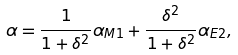<formula> <loc_0><loc_0><loc_500><loc_500>\alpha = \frac { 1 } { 1 + \delta ^ { 2 } } \alpha _ { M 1 } + \frac { \delta ^ { 2 } } { 1 + \delta ^ { 2 } } \alpha _ { E 2 } ,</formula> 